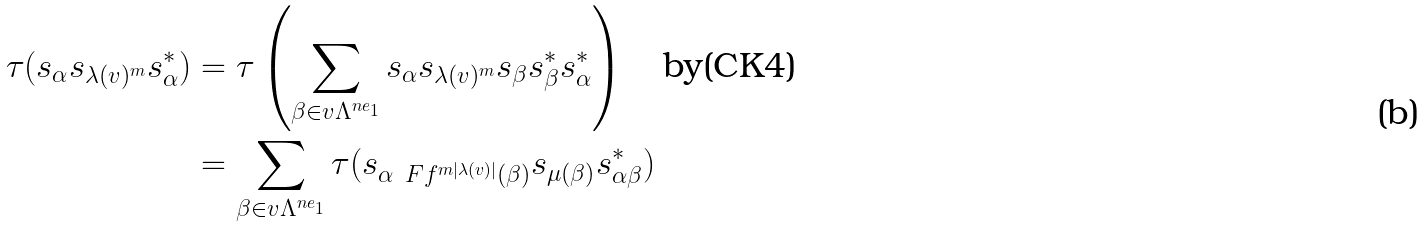<formula> <loc_0><loc_0><loc_500><loc_500>\tau ( s _ { \alpha } s _ { \lambda ( v ) ^ { m } } s ^ { * } _ { \alpha } ) & = \tau \left ( \sum _ { \beta \in v \Lambda ^ { n e _ { 1 } } } s _ { \alpha } s _ { \lambda ( v ) ^ { m } } s _ { \beta } s ^ { * } _ { \beta } s ^ { * } _ { \alpha } \right ) \quad \text {by(CK4)} \\ & = \sum _ { \beta \in v \Lambda ^ { n e _ { 1 } } } \tau ( s _ { \alpha \ F f ^ { m | \lambda ( v ) | } ( \beta ) } s _ { \mu ( \beta ) } s ^ { * } _ { \alpha \beta } )</formula> 